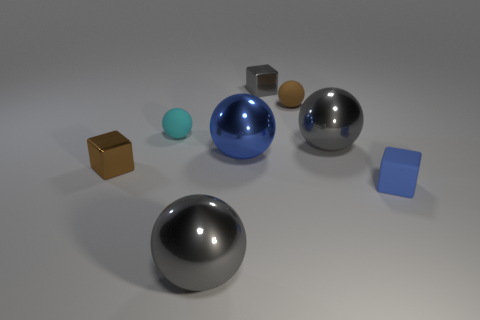Subtract 2 spheres. How many spheres are left? 3 Subtract all blue balls. How many balls are left? 4 Subtract all small brown balls. How many balls are left? 4 Subtract all purple spheres. Subtract all brown cylinders. How many spheres are left? 5 Add 2 tiny balls. How many objects exist? 10 Subtract all cubes. How many objects are left? 5 Subtract all tiny brown balls. Subtract all gray cubes. How many objects are left? 6 Add 1 large blue metal objects. How many large blue metal objects are left? 2 Add 1 big green things. How many big green things exist? 1 Subtract 1 gray blocks. How many objects are left? 7 